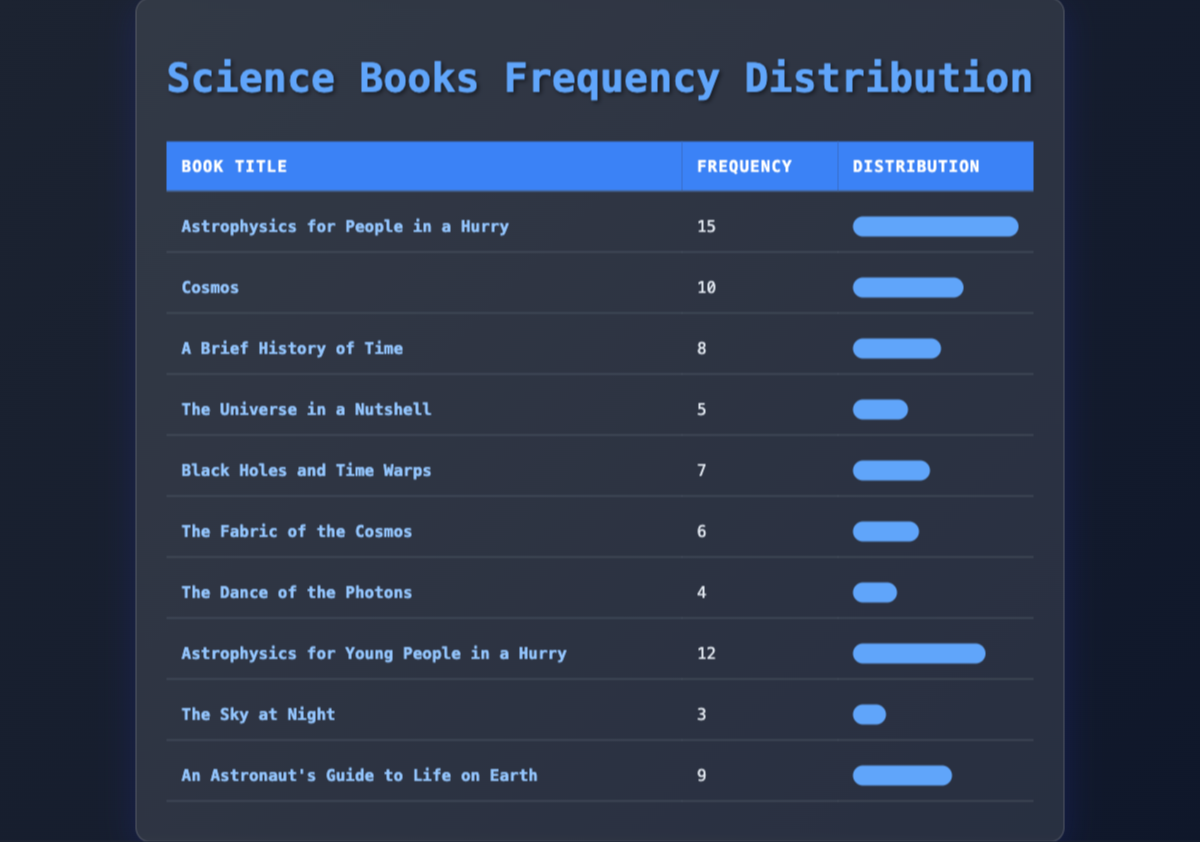What is the frequency of "Astrophysics for People in a Hurry"? The table lists the frequency for each book. The frequency for "Astrophysics for People in a Hurry" is 15.
Answer: 15 Which book has the lowest frequency of being read? By examining the frequencies, "The Sky at Night" has the lowest frequency of 3.
Answer: "The Sky at Night" What is the total frequency of the books listed in the table? To find the total frequency, we add all the individual frequencies: 15 + 10 + 8 + 5 + 7 + 6 + 4 + 12 + 3 + 9 = 79.
Answer: 79 How many books have a frequency of 7 or more? The books with frequencies 7 and above are: "Astrophysics for People in a Hurry" (15), "Astrophysics for Young People in a Hurry" (12), "Cosmos" (10), "An Astronaut's Guide to Life on Earth" (9), "Black Holes and Time Warps" (7). This gives us a total of 5 books.
Answer: 5 Is the frequency of "The Fabric of the Cosmos" higher than "The Universe in a Nutshell"? The frequency of "The Fabric of the Cosmos" is 6 and "The Universe in a Nutshell" is 5. Since 6 is greater than 5, the statement is true.
Answer: Yes What is the average frequency of the books listed? To calculate the average, we first sum the frequencies (79) and then divide by the count of books (10): 79 / 10 = 7.9. So, the average frequency is 7.9.
Answer: 7.9 Which book's frequency is closer to the average frequency of the books read? The average frequency is 7.9. The book "Black Holes and Time Warps" has a frequency of 7, which is the closest to the average when compared to other frequencies.
Answer: "Black Holes and Time Warps" What is the combined frequency of "The Dance of the Photons" and "The Sky at Night"? The frequency for "The Dance of the Photons" is 4 and for "The Sky at Night" is 3. Adding these gives: 4 + 3 = 7.
Answer: 7 Which two books have a frequency that, when combined, equals 10? "Cosmos" has a frequency of 10, and "The Dance of the Photons" has a frequency of 4. However, no two distinct books sum to 10. So, it would be impossible with given books.
Answer: No such books 